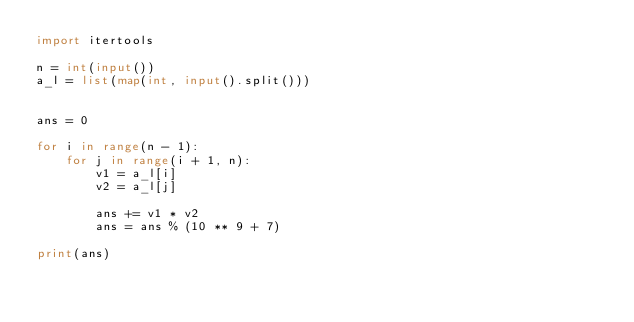<code> <loc_0><loc_0><loc_500><loc_500><_Python_>import itertools

n = int(input())
a_l = list(map(int, input().split()))


ans = 0

for i in range(n - 1):
    for j in range(i + 1, n):
        v1 = a_l[i]
        v2 = a_l[j]
        
        ans += v1 * v2
        ans = ans % (10 ** 9 + 7)

print(ans)</code> 